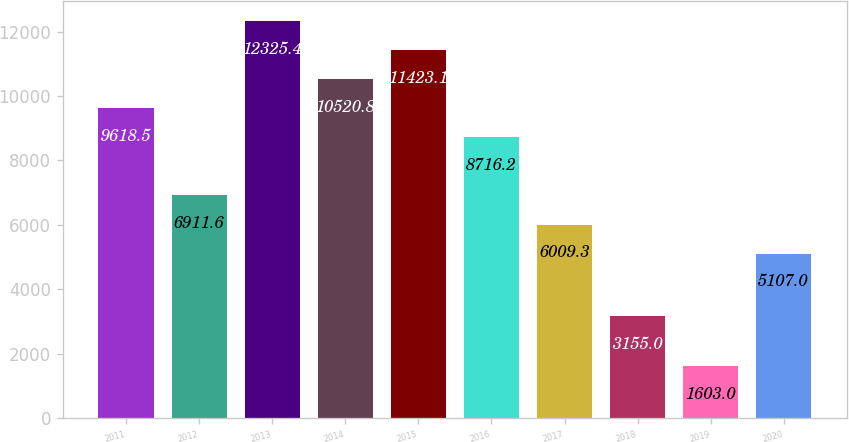<chart> <loc_0><loc_0><loc_500><loc_500><bar_chart><fcel>2011<fcel>2012<fcel>2013<fcel>2014<fcel>2015<fcel>2016<fcel>2017<fcel>2018<fcel>2019<fcel>2020<nl><fcel>9618.5<fcel>6911.6<fcel>12325.4<fcel>10520.8<fcel>11423.1<fcel>8716.2<fcel>6009.3<fcel>3155<fcel>1603<fcel>5107<nl></chart> 